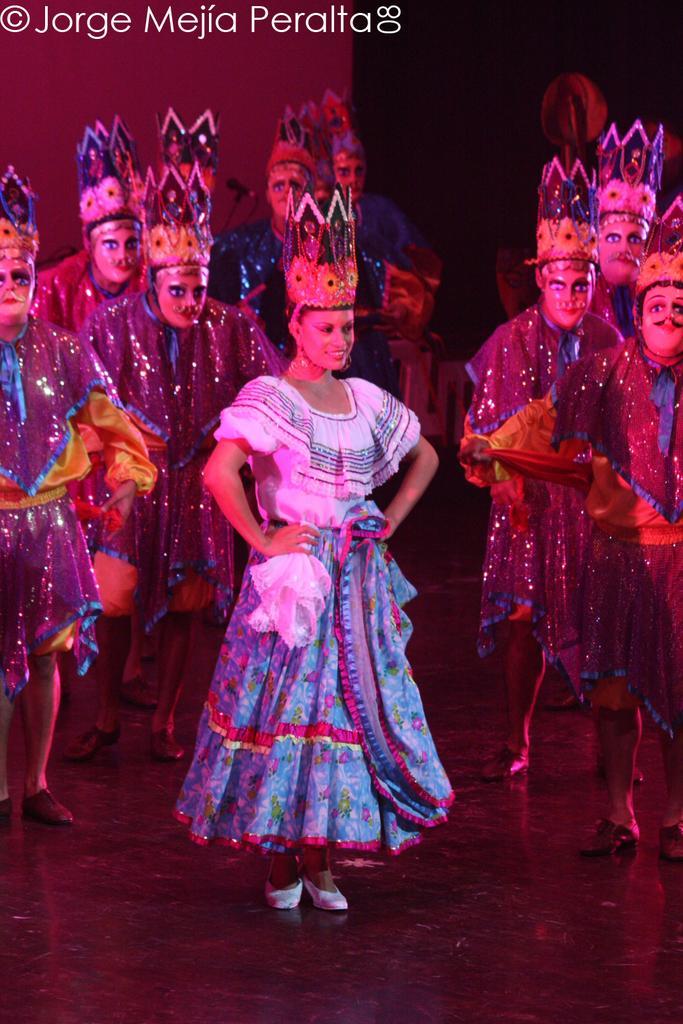In one or two sentences, can you explain what this image depicts? In this image I can see the floor and number of persons wearing costumes are standing on the floor. I can see the red and black colored background. 